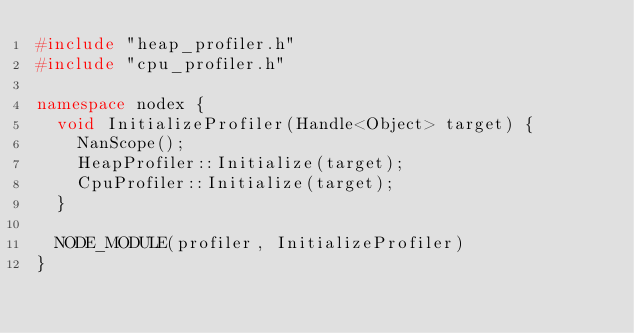<code> <loc_0><loc_0><loc_500><loc_500><_C++_>#include "heap_profiler.h"
#include "cpu_profiler.h"

namespace nodex {
  void InitializeProfiler(Handle<Object> target) {
    NanScope();
    HeapProfiler::Initialize(target);
    CpuProfiler::Initialize(target);
  }

  NODE_MODULE(profiler, InitializeProfiler)
}
</code> 